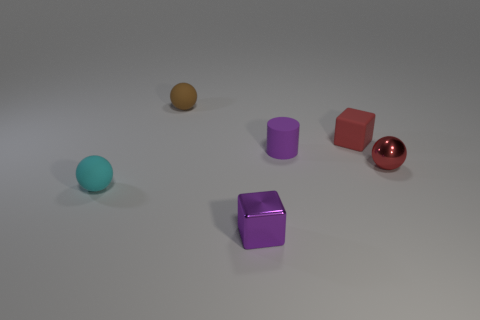What is the shape of the tiny rubber object that is both in front of the tiny red cube and to the right of the cyan ball? cylinder 